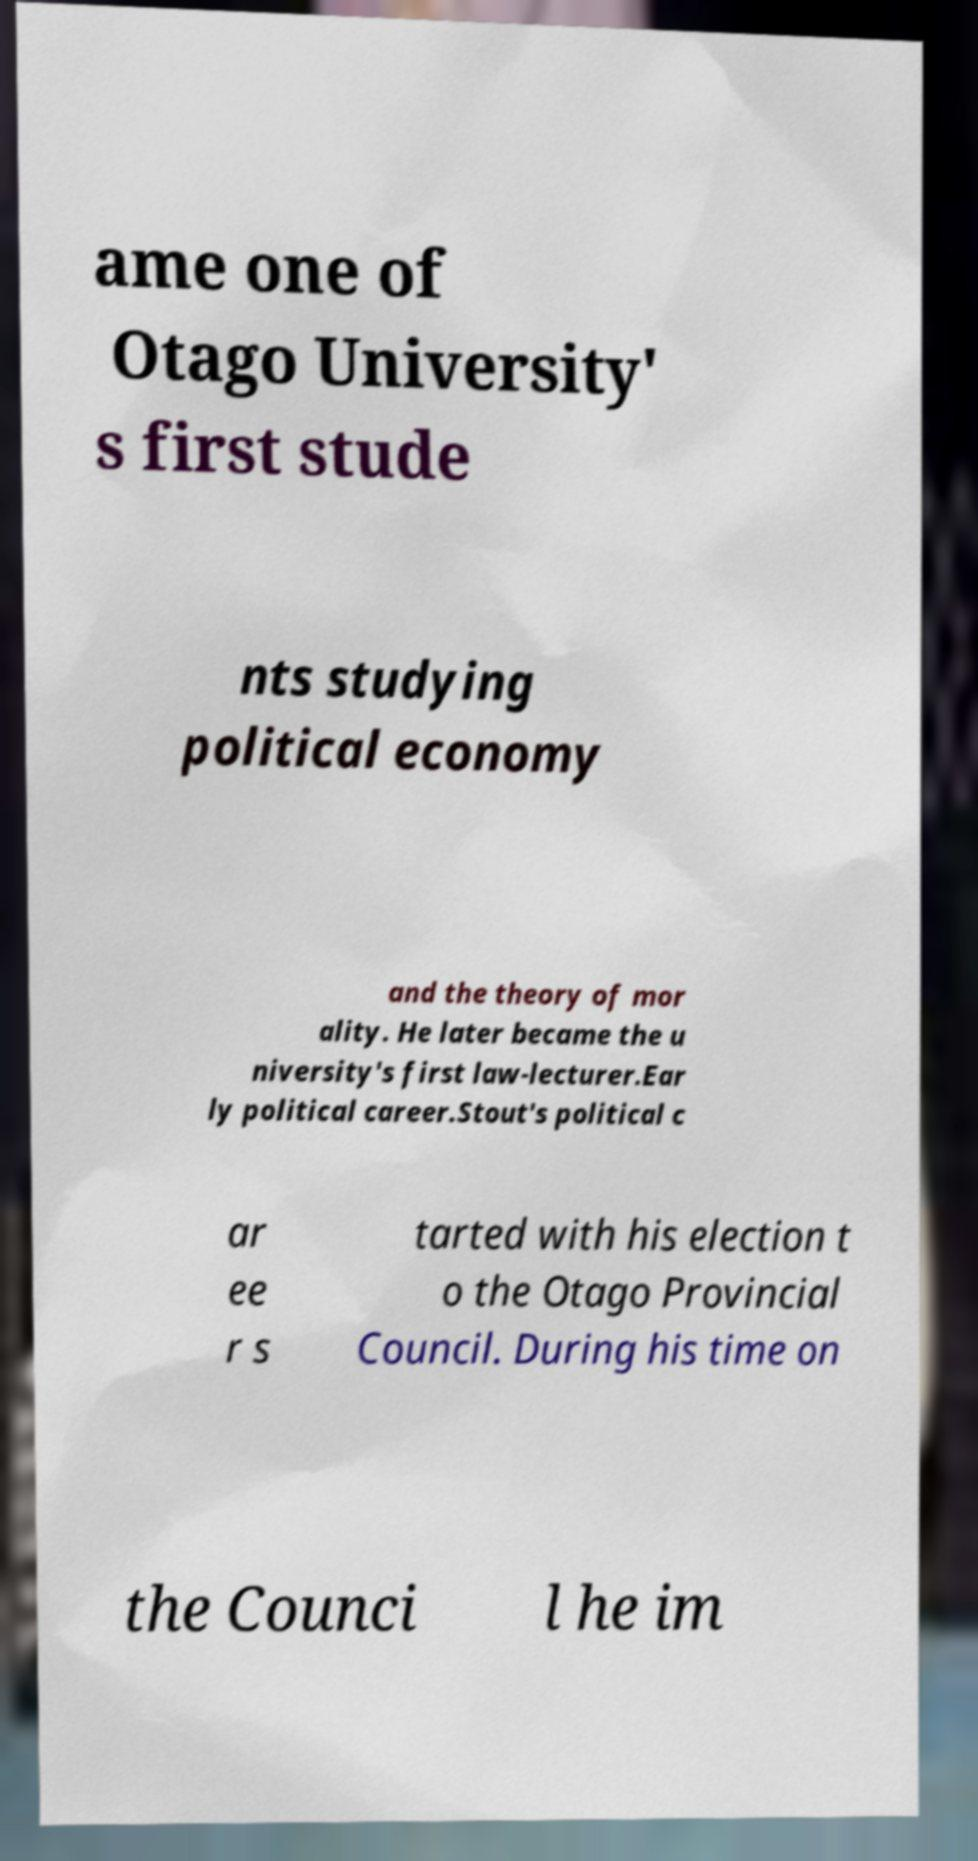Could you extract and type out the text from this image? ame one of Otago University' s first stude nts studying political economy and the theory of mor ality. He later became the u niversity's first law-lecturer.Ear ly political career.Stout's political c ar ee r s tarted with his election t o the Otago Provincial Council. During his time on the Counci l he im 